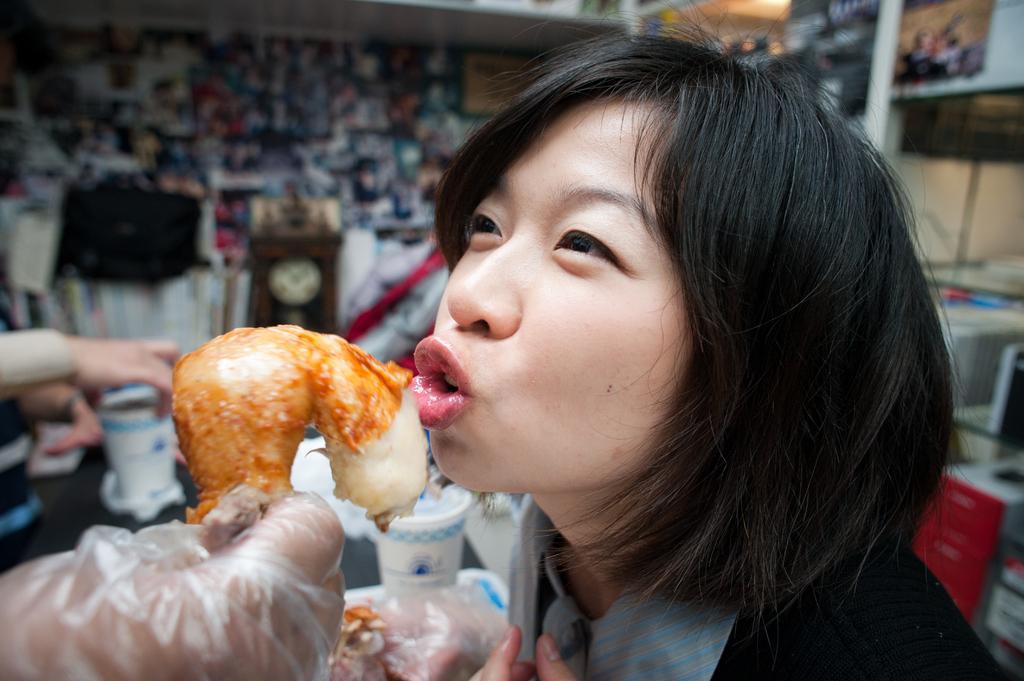Please provide a concise description of this image. In the foreground of the picture there is a woman and a person's hand holding a food item. The background is blurred. In the center of the picture there are cups, food items, tissues, a person and a table. In the background there are pictures, clock and other objects. On the right there are books. 